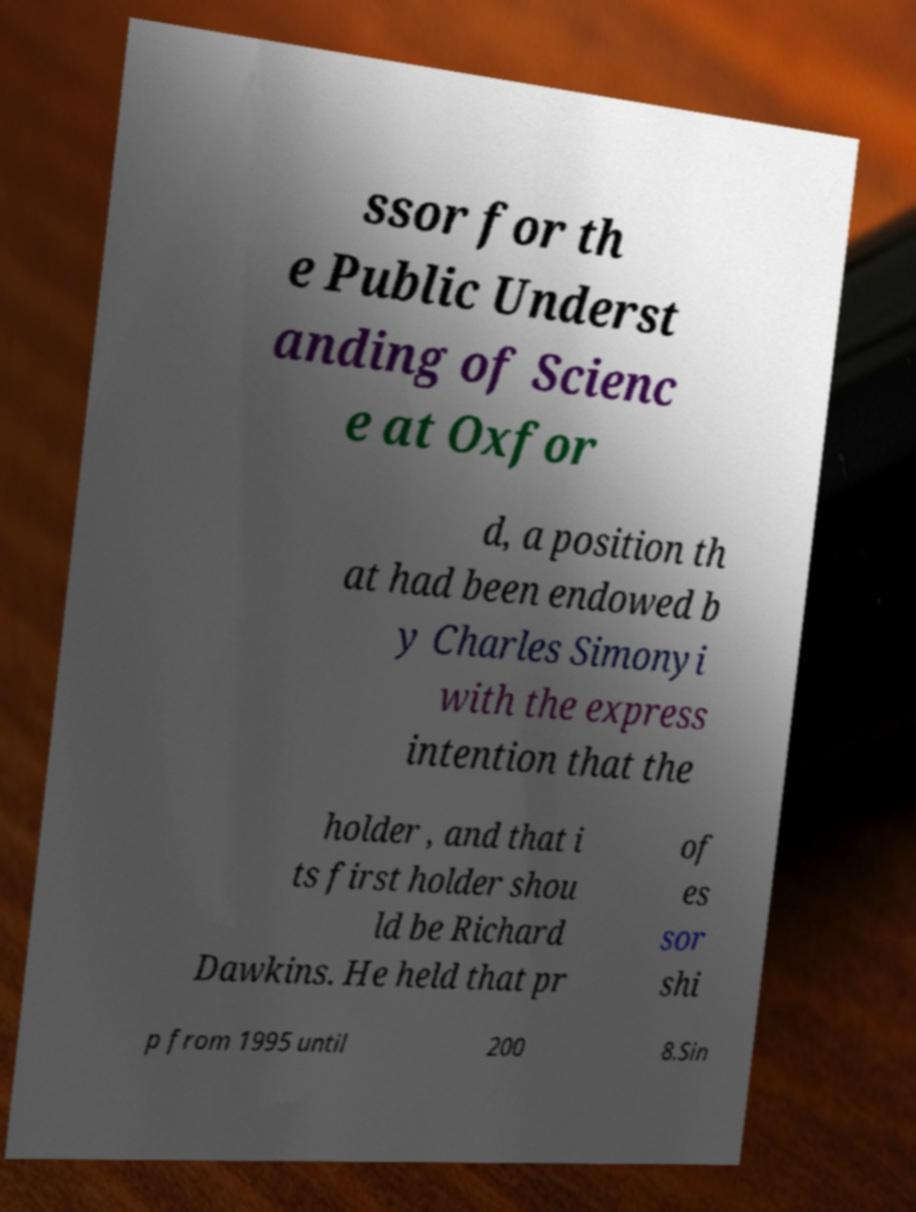Please identify and transcribe the text found in this image. ssor for th e Public Underst anding of Scienc e at Oxfor d, a position th at had been endowed b y Charles Simonyi with the express intention that the holder , and that i ts first holder shou ld be Richard Dawkins. He held that pr of es sor shi p from 1995 until 200 8.Sin 